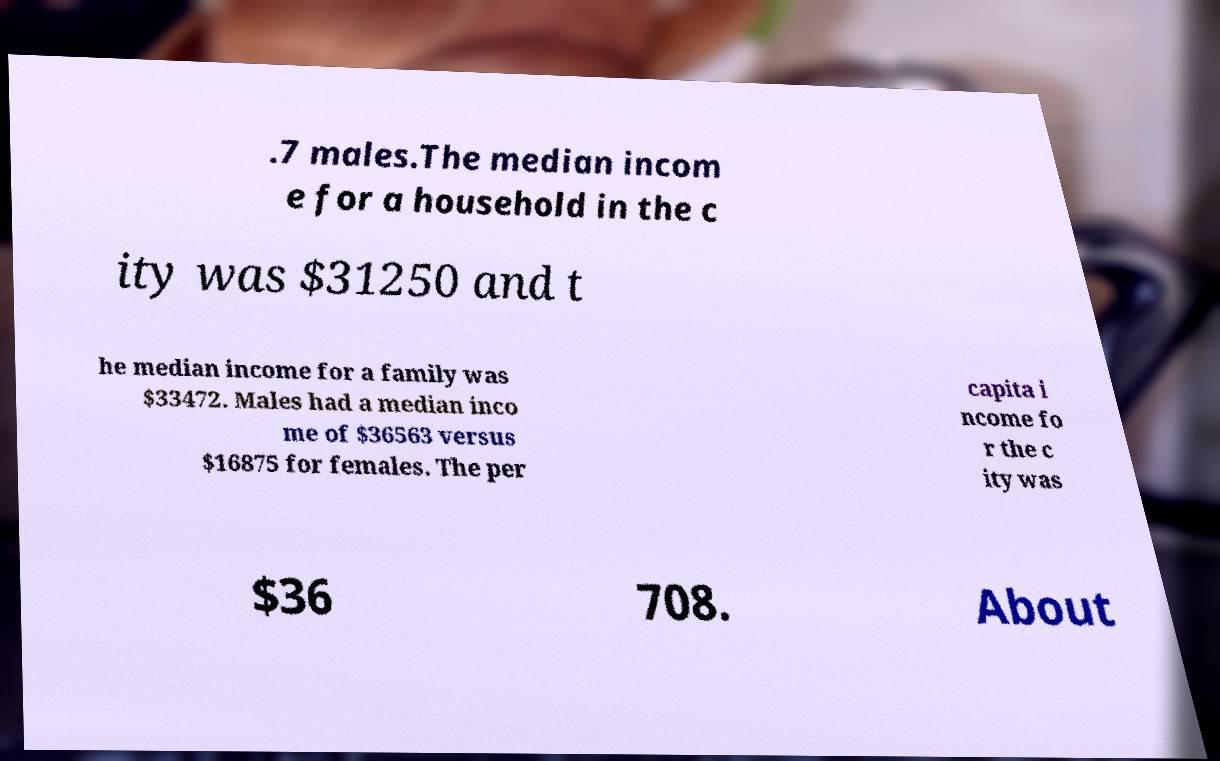I need the written content from this picture converted into text. Can you do that? .7 males.The median incom e for a household in the c ity was $31250 and t he median income for a family was $33472. Males had a median inco me of $36563 versus $16875 for females. The per capita i ncome fo r the c ity was $36 708. About 